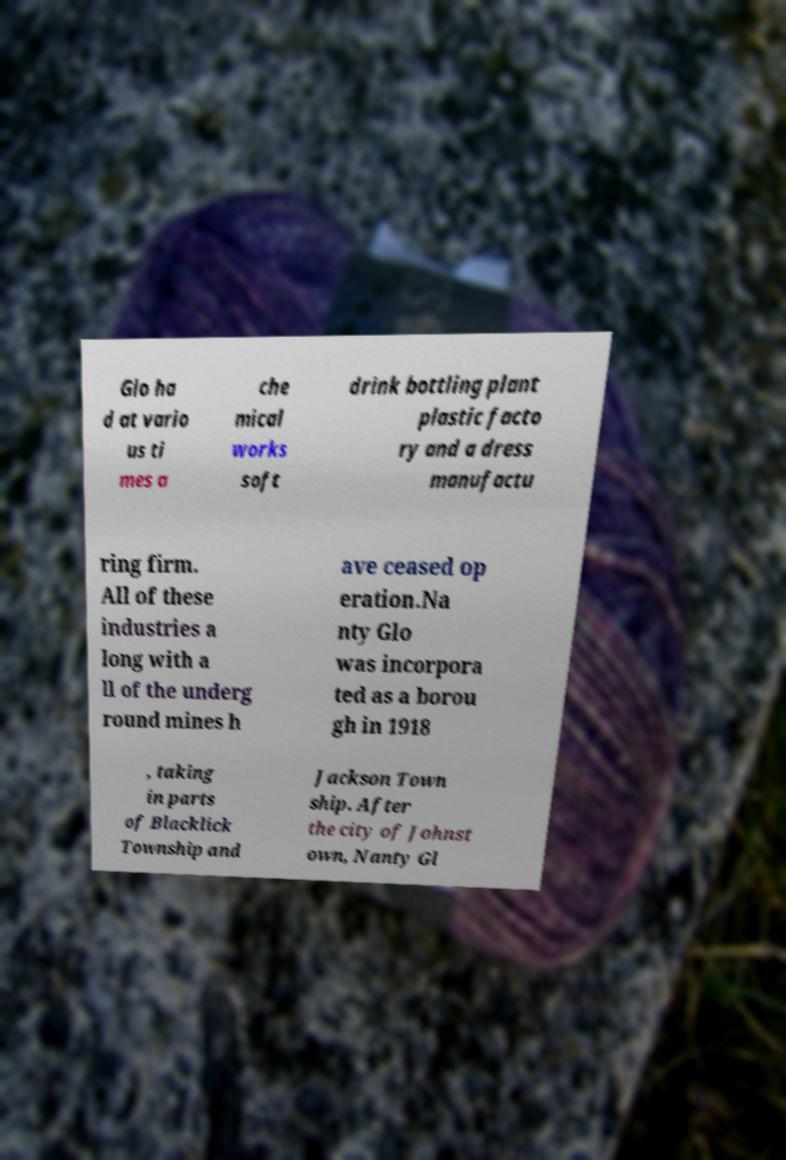Please identify and transcribe the text found in this image. Glo ha d at vario us ti mes a che mical works soft drink bottling plant plastic facto ry and a dress manufactu ring firm. All of these industries a long with a ll of the underg round mines h ave ceased op eration.Na nty Glo was incorpora ted as a borou gh in 1918 , taking in parts of Blacklick Township and Jackson Town ship. After the city of Johnst own, Nanty Gl 